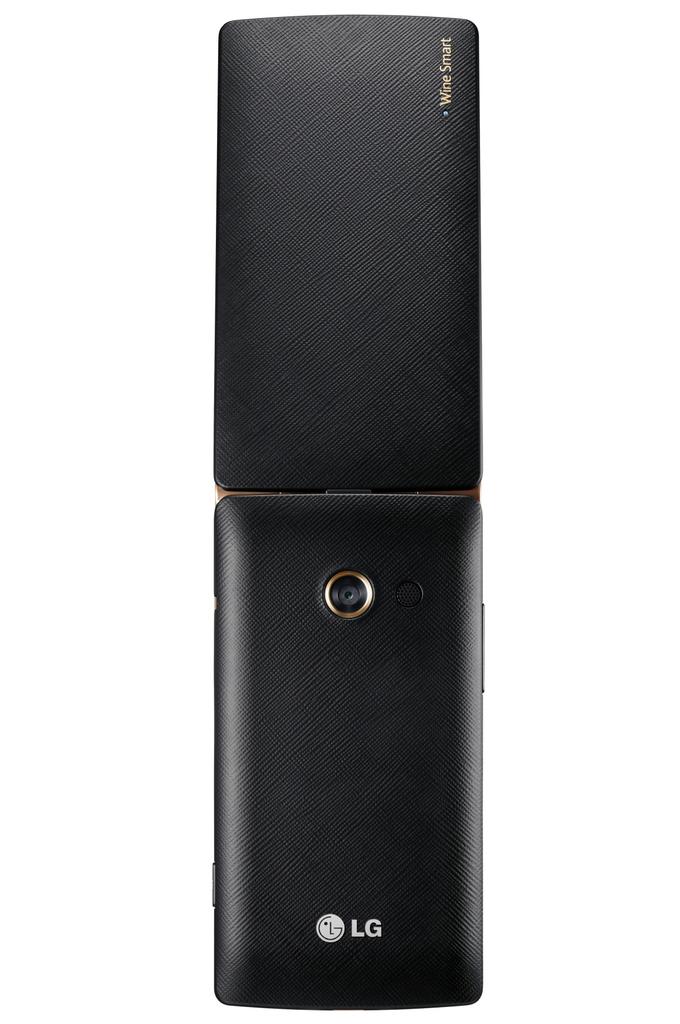Is that an lg product?
Provide a short and direct response. Yes. 